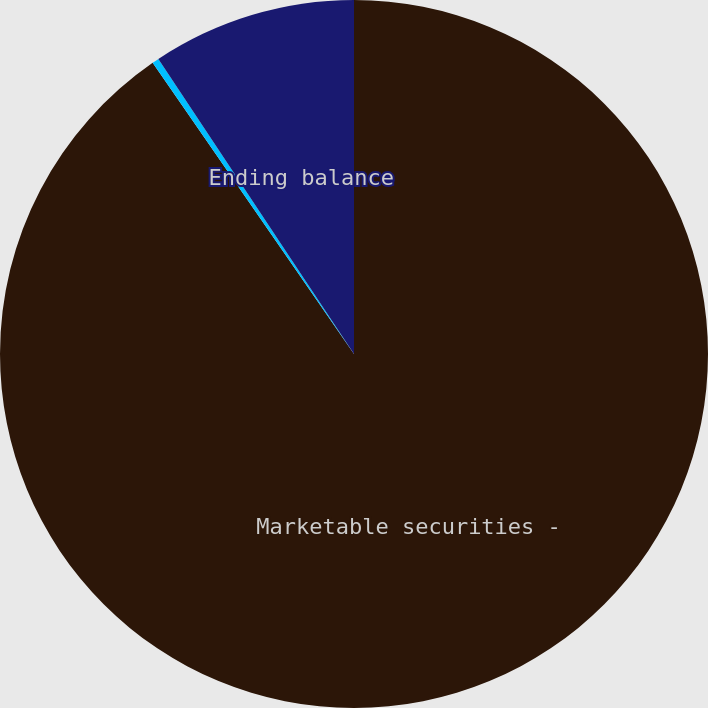Convert chart. <chart><loc_0><loc_0><loc_500><loc_500><pie_chart><fcel>Marketable securities -<fcel>Beginning balance<fcel>Ending balance<nl><fcel>90.37%<fcel>0.31%<fcel>9.32%<nl></chart> 